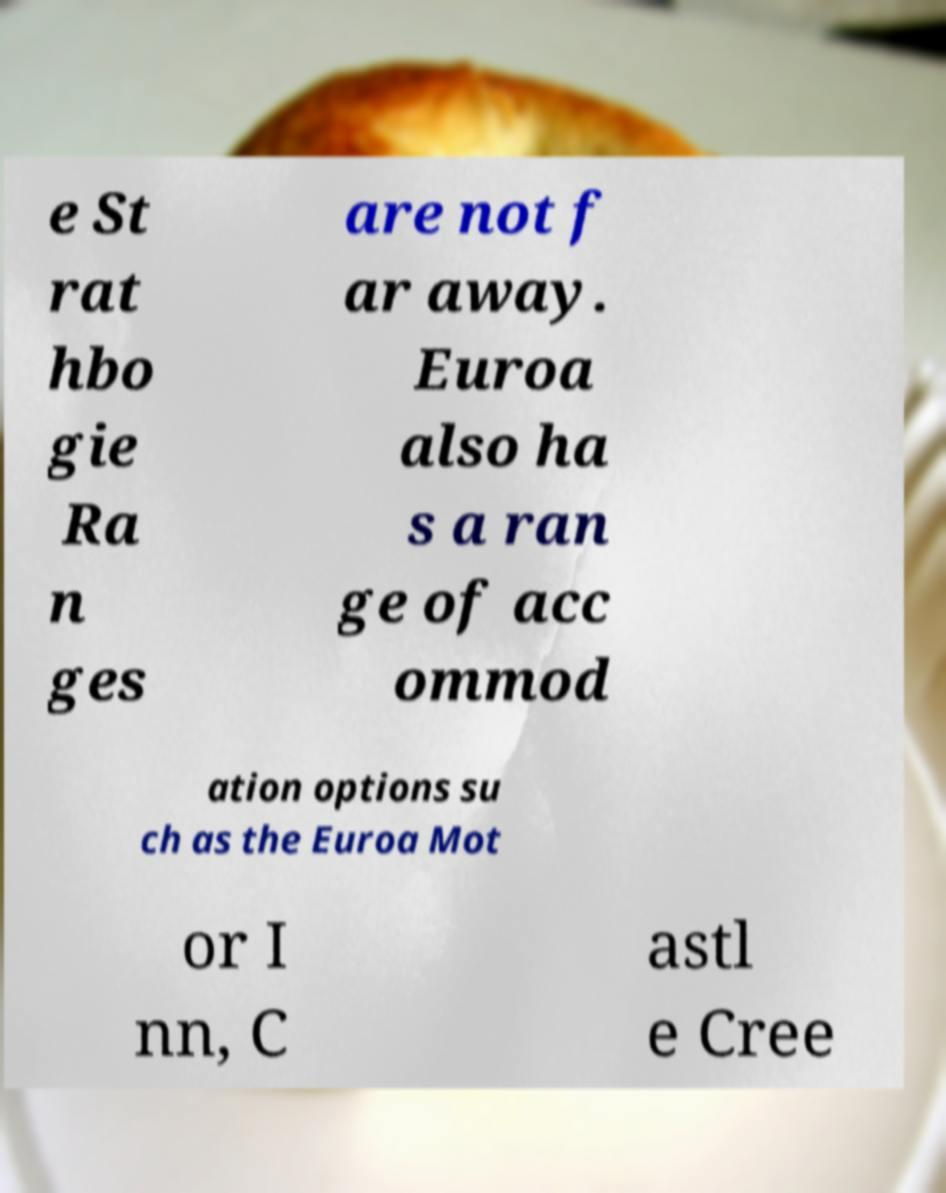Could you extract and type out the text from this image? e St rat hbo gie Ra n ges are not f ar away. Euroa also ha s a ran ge of acc ommod ation options su ch as the Euroa Mot or I nn, C astl e Cree 